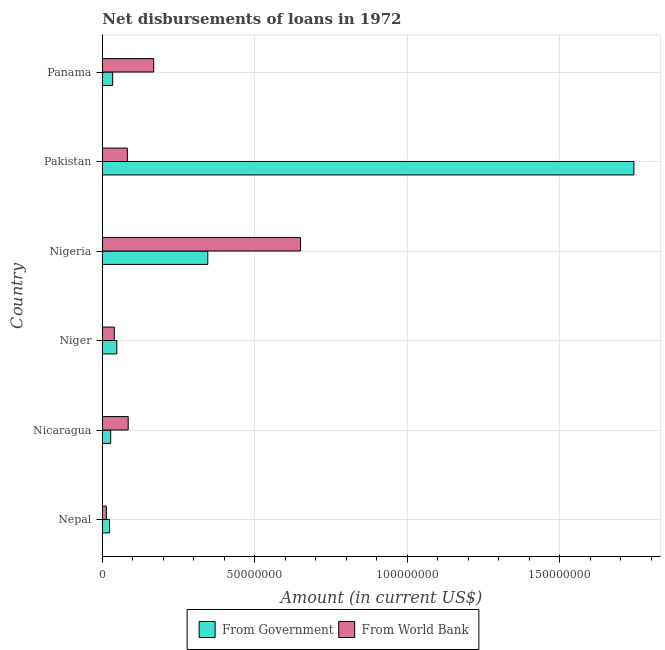Are the number of bars per tick equal to the number of legend labels?
Offer a very short reply. Yes. How many bars are there on the 2nd tick from the top?
Provide a succinct answer. 2. What is the label of the 5th group of bars from the top?
Your answer should be compact. Nicaragua. In how many cases, is the number of bars for a given country not equal to the number of legend labels?
Offer a terse response. 0. What is the net disbursements of loan from world bank in Nepal?
Provide a short and direct response. 1.28e+06. Across all countries, what is the maximum net disbursements of loan from government?
Provide a short and direct response. 1.74e+08. Across all countries, what is the minimum net disbursements of loan from government?
Provide a short and direct response. 2.33e+06. In which country was the net disbursements of loan from government maximum?
Provide a succinct answer. Pakistan. In which country was the net disbursements of loan from world bank minimum?
Provide a succinct answer. Nepal. What is the total net disbursements of loan from world bank in the graph?
Make the answer very short. 1.04e+08. What is the difference between the net disbursements of loan from world bank in Niger and that in Pakistan?
Offer a very short reply. -4.28e+06. What is the difference between the net disbursements of loan from world bank in Nigeria and the net disbursements of loan from government in Pakistan?
Keep it short and to the point. -1.09e+08. What is the average net disbursements of loan from government per country?
Your answer should be very brief. 3.70e+07. What is the difference between the net disbursements of loan from world bank and net disbursements of loan from government in Nigeria?
Make the answer very short. 3.04e+07. What is the ratio of the net disbursements of loan from world bank in Nigeria to that in Panama?
Offer a very short reply. 3.87. Is the net disbursements of loan from world bank in Nigeria less than that in Pakistan?
Provide a succinct answer. No. Is the difference between the net disbursements of loan from world bank in Nepal and Nicaragua greater than the difference between the net disbursements of loan from government in Nepal and Nicaragua?
Make the answer very short. No. What is the difference between the highest and the second highest net disbursements of loan from government?
Your response must be concise. 1.40e+08. What is the difference between the highest and the lowest net disbursements of loan from government?
Keep it short and to the point. 1.72e+08. In how many countries, is the net disbursements of loan from world bank greater than the average net disbursements of loan from world bank taken over all countries?
Your answer should be very brief. 1. Is the sum of the net disbursements of loan from government in Nicaragua and Pakistan greater than the maximum net disbursements of loan from world bank across all countries?
Provide a succinct answer. Yes. What does the 1st bar from the top in Pakistan represents?
Offer a terse response. From World Bank. What does the 1st bar from the bottom in Nicaragua represents?
Your answer should be compact. From Government. How many bars are there?
Give a very brief answer. 12. How many countries are there in the graph?
Give a very brief answer. 6. Are the values on the major ticks of X-axis written in scientific E-notation?
Offer a terse response. No. Does the graph contain grids?
Make the answer very short. Yes. Where does the legend appear in the graph?
Your response must be concise. Bottom center. How are the legend labels stacked?
Ensure brevity in your answer.  Horizontal. What is the title of the graph?
Your answer should be compact. Net disbursements of loans in 1972. Does "Female labourers" appear as one of the legend labels in the graph?
Give a very brief answer. No. What is the label or title of the X-axis?
Make the answer very short. Amount (in current US$). What is the Amount (in current US$) in From Government in Nepal?
Provide a succinct answer. 2.33e+06. What is the Amount (in current US$) of From World Bank in Nepal?
Your response must be concise. 1.28e+06. What is the Amount (in current US$) of From Government in Nicaragua?
Make the answer very short. 2.70e+06. What is the Amount (in current US$) of From World Bank in Nicaragua?
Make the answer very short. 8.44e+06. What is the Amount (in current US$) in From Government in Niger?
Your response must be concise. 4.70e+06. What is the Amount (in current US$) of From World Bank in Niger?
Your answer should be compact. 3.89e+06. What is the Amount (in current US$) in From Government in Nigeria?
Offer a very short reply. 3.45e+07. What is the Amount (in current US$) of From World Bank in Nigeria?
Make the answer very short. 6.50e+07. What is the Amount (in current US$) of From Government in Pakistan?
Your answer should be compact. 1.74e+08. What is the Amount (in current US$) in From World Bank in Pakistan?
Provide a short and direct response. 8.17e+06. What is the Amount (in current US$) in From Government in Panama?
Your answer should be compact. 3.34e+06. What is the Amount (in current US$) of From World Bank in Panama?
Make the answer very short. 1.68e+07. Across all countries, what is the maximum Amount (in current US$) in From Government?
Your answer should be very brief. 1.74e+08. Across all countries, what is the maximum Amount (in current US$) in From World Bank?
Your response must be concise. 6.50e+07. Across all countries, what is the minimum Amount (in current US$) of From Government?
Your answer should be compact. 2.33e+06. Across all countries, what is the minimum Amount (in current US$) in From World Bank?
Provide a succinct answer. 1.28e+06. What is the total Amount (in current US$) in From Government in the graph?
Offer a terse response. 2.22e+08. What is the total Amount (in current US$) of From World Bank in the graph?
Your answer should be very brief. 1.04e+08. What is the difference between the Amount (in current US$) in From Government in Nepal and that in Nicaragua?
Ensure brevity in your answer.  -3.72e+05. What is the difference between the Amount (in current US$) in From World Bank in Nepal and that in Nicaragua?
Make the answer very short. -7.16e+06. What is the difference between the Amount (in current US$) in From Government in Nepal and that in Niger?
Your answer should be very brief. -2.38e+06. What is the difference between the Amount (in current US$) of From World Bank in Nepal and that in Niger?
Provide a short and direct response. -2.61e+06. What is the difference between the Amount (in current US$) of From Government in Nepal and that in Nigeria?
Make the answer very short. -3.22e+07. What is the difference between the Amount (in current US$) in From World Bank in Nepal and that in Nigeria?
Provide a succinct answer. -6.37e+07. What is the difference between the Amount (in current US$) of From Government in Nepal and that in Pakistan?
Your answer should be compact. -1.72e+08. What is the difference between the Amount (in current US$) in From World Bank in Nepal and that in Pakistan?
Offer a terse response. -6.89e+06. What is the difference between the Amount (in current US$) in From Government in Nepal and that in Panama?
Offer a very short reply. -1.02e+06. What is the difference between the Amount (in current US$) of From World Bank in Nepal and that in Panama?
Your answer should be very brief. -1.55e+07. What is the difference between the Amount (in current US$) in From Government in Nicaragua and that in Niger?
Your response must be concise. -2.00e+06. What is the difference between the Amount (in current US$) in From World Bank in Nicaragua and that in Niger?
Make the answer very short. 4.55e+06. What is the difference between the Amount (in current US$) in From Government in Nicaragua and that in Nigeria?
Offer a terse response. -3.18e+07. What is the difference between the Amount (in current US$) of From World Bank in Nicaragua and that in Nigeria?
Your answer should be compact. -5.65e+07. What is the difference between the Amount (in current US$) of From Government in Nicaragua and that in Pakistan?
Ensure brevity in your answer.  -1.72e+08. What is the difference between the Amount (in current US$) of From World Bank in Nicaragua and that in Pakistan?
Keep it short and to the point. 2.72e+05. What is the difference between the Amount (in current US$) of From Government in Nicaragua and that in Panama?
Offer a very short reply. -6.45e+05. What is the difference between the Amount (in current US$) in From World Bank in Nicaragua and that in Panama?
Your response must be concise. -8.37e+06. What is the difference between the Amount (in current US$) of From Government in Niger and that in Nigeria?
Your answer should be compact. -2.98e+07. What is the difference between the Amount (in current US$) in From World Bank in Niger and that in Nigeria?
Your answer should be very brief. -6.11e+07. What is the difference between the Amount (in current US$) in From Government in Niger and that in Pakistan?
Your response must be concise. -1.70e+08. What is the difference between the Amount (in current US$) in From World Bank in Niger and that in Pakistan?
Ensure brevity in your answer.  -4.28e+06. What is the difference between the Amount (in current US$) in From Government in Niger and that in Panama?
Your answer should be very brief. 1.36e+06. What is the difference between the Amount (in current US$) of From World Bank in Niger and that in Panama?
Offer a very short reply. -1.29e+07. What is the difference between the Amount (in current US$) in From Government in Nigeria and that in Pakistan?
Offer a very short reply. -1.40e+08. What is the difference between the Amount (in current US$) of From World Bank in Nigeria and that in Pakistan?
Provide a succinct answer. 5.68e+07. What is the difference between the Amount (in current US$) in From Government in Nigeria and that in Panama?
Your answer should be compact. 3.12e+07. What is the difference between the Amount (in current US$) in From World Bank in Nigeria and that in Panama?
Make the answer very short. 4.82e+07. What is the difference between the Amount (in current US$) of From Government in Pakistan and that in Panama?
Give a very brief answer. 1.71e+08. What is the difference between the Amount (in current US$) in From World Bank in Pakistan and that in Panama?
Your answer should be very brief. -8.64e+06. What is the difference between the Amount (in current US$) of From Government in Nepal and the Amount (in current US$) of From World Bank in Nicaragua?
Keep it short and to the point. -6.11e+06. What is the difference between the Amount (in current US$) of From Government in Nepal and the Amount (in current US$) of From World Bank in Niger?
Offer a very short reply. -1.56e+06. What is the difference between the Amount (in current US$) of From Government in Nepal and the Amount (in current US$) of From World Bank in Nigeria?
Provide a short and direct response. -6.26e+07. What is the difference between the Amount (in current US$) in From Government in Nepal and the Amount (in current US$) in From World Bank in Pakistan?
Offer a terse response. -5.84e+06. What is the difference between the Amount (in current US$) of From Government in Nepal and the Amount (in current US$) of From World Bank in Panama?
Your response must be concise. -1.45e+07. What is the difference between the Amount (in current US$) of From Government in Nicaragua and the Amount (in current US$) of From World Bank in Niger?
Your response must be concise. -1.19e+06. What is the difference between the Amount (in current US$) of From Government in Nicaragua and the Amount (in current US$) of From World Bank in Nigeria?
Provide a short and direct response. -6.23e+07. What is the difference between the Amount (in current US$) of From Government in Nicaragua and the Amount (in current US$) of From World Bank in Pakistan?
Give a very brief answer. -5.47e+06. What is the difference between the Amount (in current US$) of From Government in Nicaragua and the Amount (in current US$) of From World Bank in Panama?
Your response must be concise. -1.41e+07. What is the difference between the Amount (in current US$) in From Government in Niger and the Amount (in current US$) in From World Bank in Nigeria?
Give a very brief answer. -6.03e+07. What is the difference between the Amount (in current US$) of From Government in Niger and the Amount (in current US$) of From World Bank in Pakistan?
Give a very brief answer. -3.46e+06. What is the difference between the Amount (in current US$) of From Government in Niger and the Amount (in current US$) of From World Bank in Panama?
Offer a very short reply. -1.21e+07. What is the difference between the Amount (in current US$) of From Government in Nigeria and the Amount (in current US$) of From World Bank in Pakistan?
Offer a terse response. 2.64e+07. What is the difference between the Amount (in current US$) of From Government in Nigeria and the Amount (in current US$) of From World Bank in Panama?
Offer a very short reply. 1.77e+07. What is the difference between the Amount (in current US$) in From Government in Pakistan and the Amount (in current US$) in From World Bank in Panama?
Give a very brief answer. 1.57e+08. What is the average Amount (in current US$) of From Government per country?
Provide a succinct answer. 3.70e+07. What is the average Amount (in current US$) of From World Bank per country?
Offer a very short reply. 1.73e+07. What is the difference between the Amount (in current US$) in From Government and Amount (in current US$) in From World Bank in Nepal?
Keep it short and to the point. 1.05e+06. What is the difference between the Amount (in current US$) of From Government and Amount (in current US$) of From World Bank in Nicaragua?
Your response must be concise. -5.74e+06. What is the difference between the Amount (in current US$) of From Government and Amount (in current US$) of From World Bank in Niger?
Offer a very short reply. 8.18e+05. What is the difference between the Amount (in current US$) in From Government and Amount (in current US$) in From World Bank in Nigeria?
Your response must be concise. -3.04e+07. What is the difference between the Amount (in current US$) in From Government and Amount (in current US$) in From World Bank in Pakistan?
Provide a succinct answer. 1.66e+08. What is the difference between the Amount (in current US$) in From Government and Amount (in current US$) in From World Bank in Panama?
Your answer should be compact. -1.35e+07. What is the ratio of the Amount (in current US$) in From Government in Nepal to that in Nicaragua?
Provide a short and direct response. 0.86. What is the ratio of the Amount (in current US$) in From World Bank in Nepal to that in Nicaragua?
Your answer should be compact. 0.15. What is the ratio of the Amount (in current US$) of From Government in Nepal to that in Niger?
Offer a terse response. 0.49. What is the ratio of the Amount (in current US$) of From World Bank in Nepal to that in Niger?
Ensure brevity in your answer.  0.33. What is the ratio of the Amount (in current US$) in From Government in Nepal to that in Nigeria?
Offer a terse response. 0.07. What is the ratio of the Amount (in current US$) in From World Bank in Nepal to that in Nigeria?
Offer a very short reply. 0.02. What is the ratio of the Amount (in current US$) in From Government in Nepal to that in Pakistan?
Provide a succinct answer. 0.01. What is the ratio of the Amount (in current US$) in From World Bank in Nepal to that in Pakistan?
Make the answer very short. 0.16. What is the ratio of the Amount (in current US$) of From Government in Nepal to that in Panama?
Give a very brief answer. 0.7. What is the ratio of the Amount (in current US$) in From World Bank in Nepal to that in Panama?
Provide a succinct answer. 0.08. What is the ratio of the Amount (in current US$) in From Government in Nicaragua to that in Niger?
Your response must be concise. 0.57. What is the ratio of the Amount (in current US$) in From World Bank in Nicaragua to that in Niger?
Your answer should be very brief. 2.17. What is the ratio of the Amount (in current US$) in From Government in Nicaragua to that in Nigeria?
Your response must be concise. 0.08. What is the ratio of the Amount (in current US$) of From World Bank in Nicaragua to that in Nigeria?
Keep it short and to the point. 0.13. What is the ratio of the Amount (in current US$) in From Government in Nicaragua to that in Pakistan?
Ensure brevity in your answer.  0.02. What is the ratio of the Amount (in current US$) in From Government in Nicaragua to that in Panama?
Keep it short and to the point. 0.81. What is the ratio of the Amount (in current US$) in From World Bank in Nicaragua to that in Panama?
Ensure brevity in your answer.  0.5. What is the ratio of the Amount (in current US$) of From Government in Niger to that in Nigeria?
Offer a terse response. 0.14. What is the ratio of the Amount (in current US$) in From World Bank in Niger to that in Nigeria?
Your response must be concise. 0.06. What is the ratio of the Amount (in current US$) of From Government in Niger to that in Pakistan?
Give a very brief answer. 0.03. What is the ratio of the Amount (in current US$) of From World Bank in Niger to that in Pakistan?
Your answer should be compact. 0.48. What is the ratio of the Amount (in current US$) of From Government in Niger to that in Panama?
Make the answer very short. 1.41. What is the ratio of the Amount (in current US$) of From World Bank in Niger to that in Panama?
Ensure brevity in your answer.  0.23. What is the ratio of the Amount (in current US$) of From Government in Nigeria to that in Pakistan?
Keep it short and to the point. 0.2. What is the ratio of the Amount (in current US$) of From World Bank in Nigeria to that in Pakistan?
Provide a succinct answer. 7.96. What is the ratio of the Amount (in current US$) in From Government in Nigeria to that in Panama?
Your response must be concise. 10.33. What is the ratio of the Amount (in current US$) in From World Bank in Nigeria to that in Panama?
Offer a terse response. 3.87. What is the ratio of the Amount (in current US$) in From Government in Pakistan to that in Panama?
Provide a succinct answer. 52.11. What is the ratio of the Amount (in current US$) in From World Bank in Pakistan to that in Panama?
Ensure brevity in your answer.  0.49. What is the difference between the highest and the second highest Amount (in current US$) of From Government?
Ensure brevity in your answer.  1.40e+08. What is the difference between the highest and the second highest Amount (in current US$) in From World Bank?
Keep it short and to the point. 4.82e+07. What is the difference between the highest and the lowest Amount (in current US$) of From Government?
Your response must be concise. 1.72e+08. What is the difference between the highest and the lowest Amount (in current US$) of From World Bank?
Ensure brevity in your answer.  6.37e+07. 